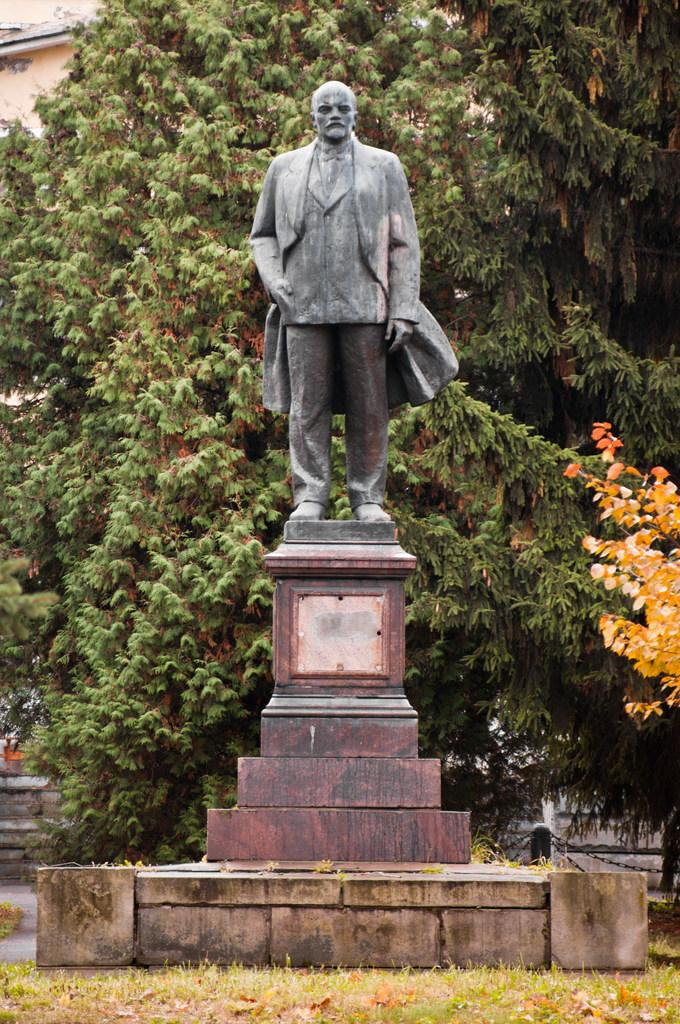What is the main subject of the image? There is a statue in the image. What type of statue is it? The statue appears to be a memorial. What can be seen in the background of the image? There are trees and a building behind the statue. How does the statue say good-bye to people in the image? The statue is an inanimate object and cannot say good-bye or interact with people in the image. What type of bean is growing on the statue in the image? There are no beans present in the image; it features a statue and a background with trees and a building. 